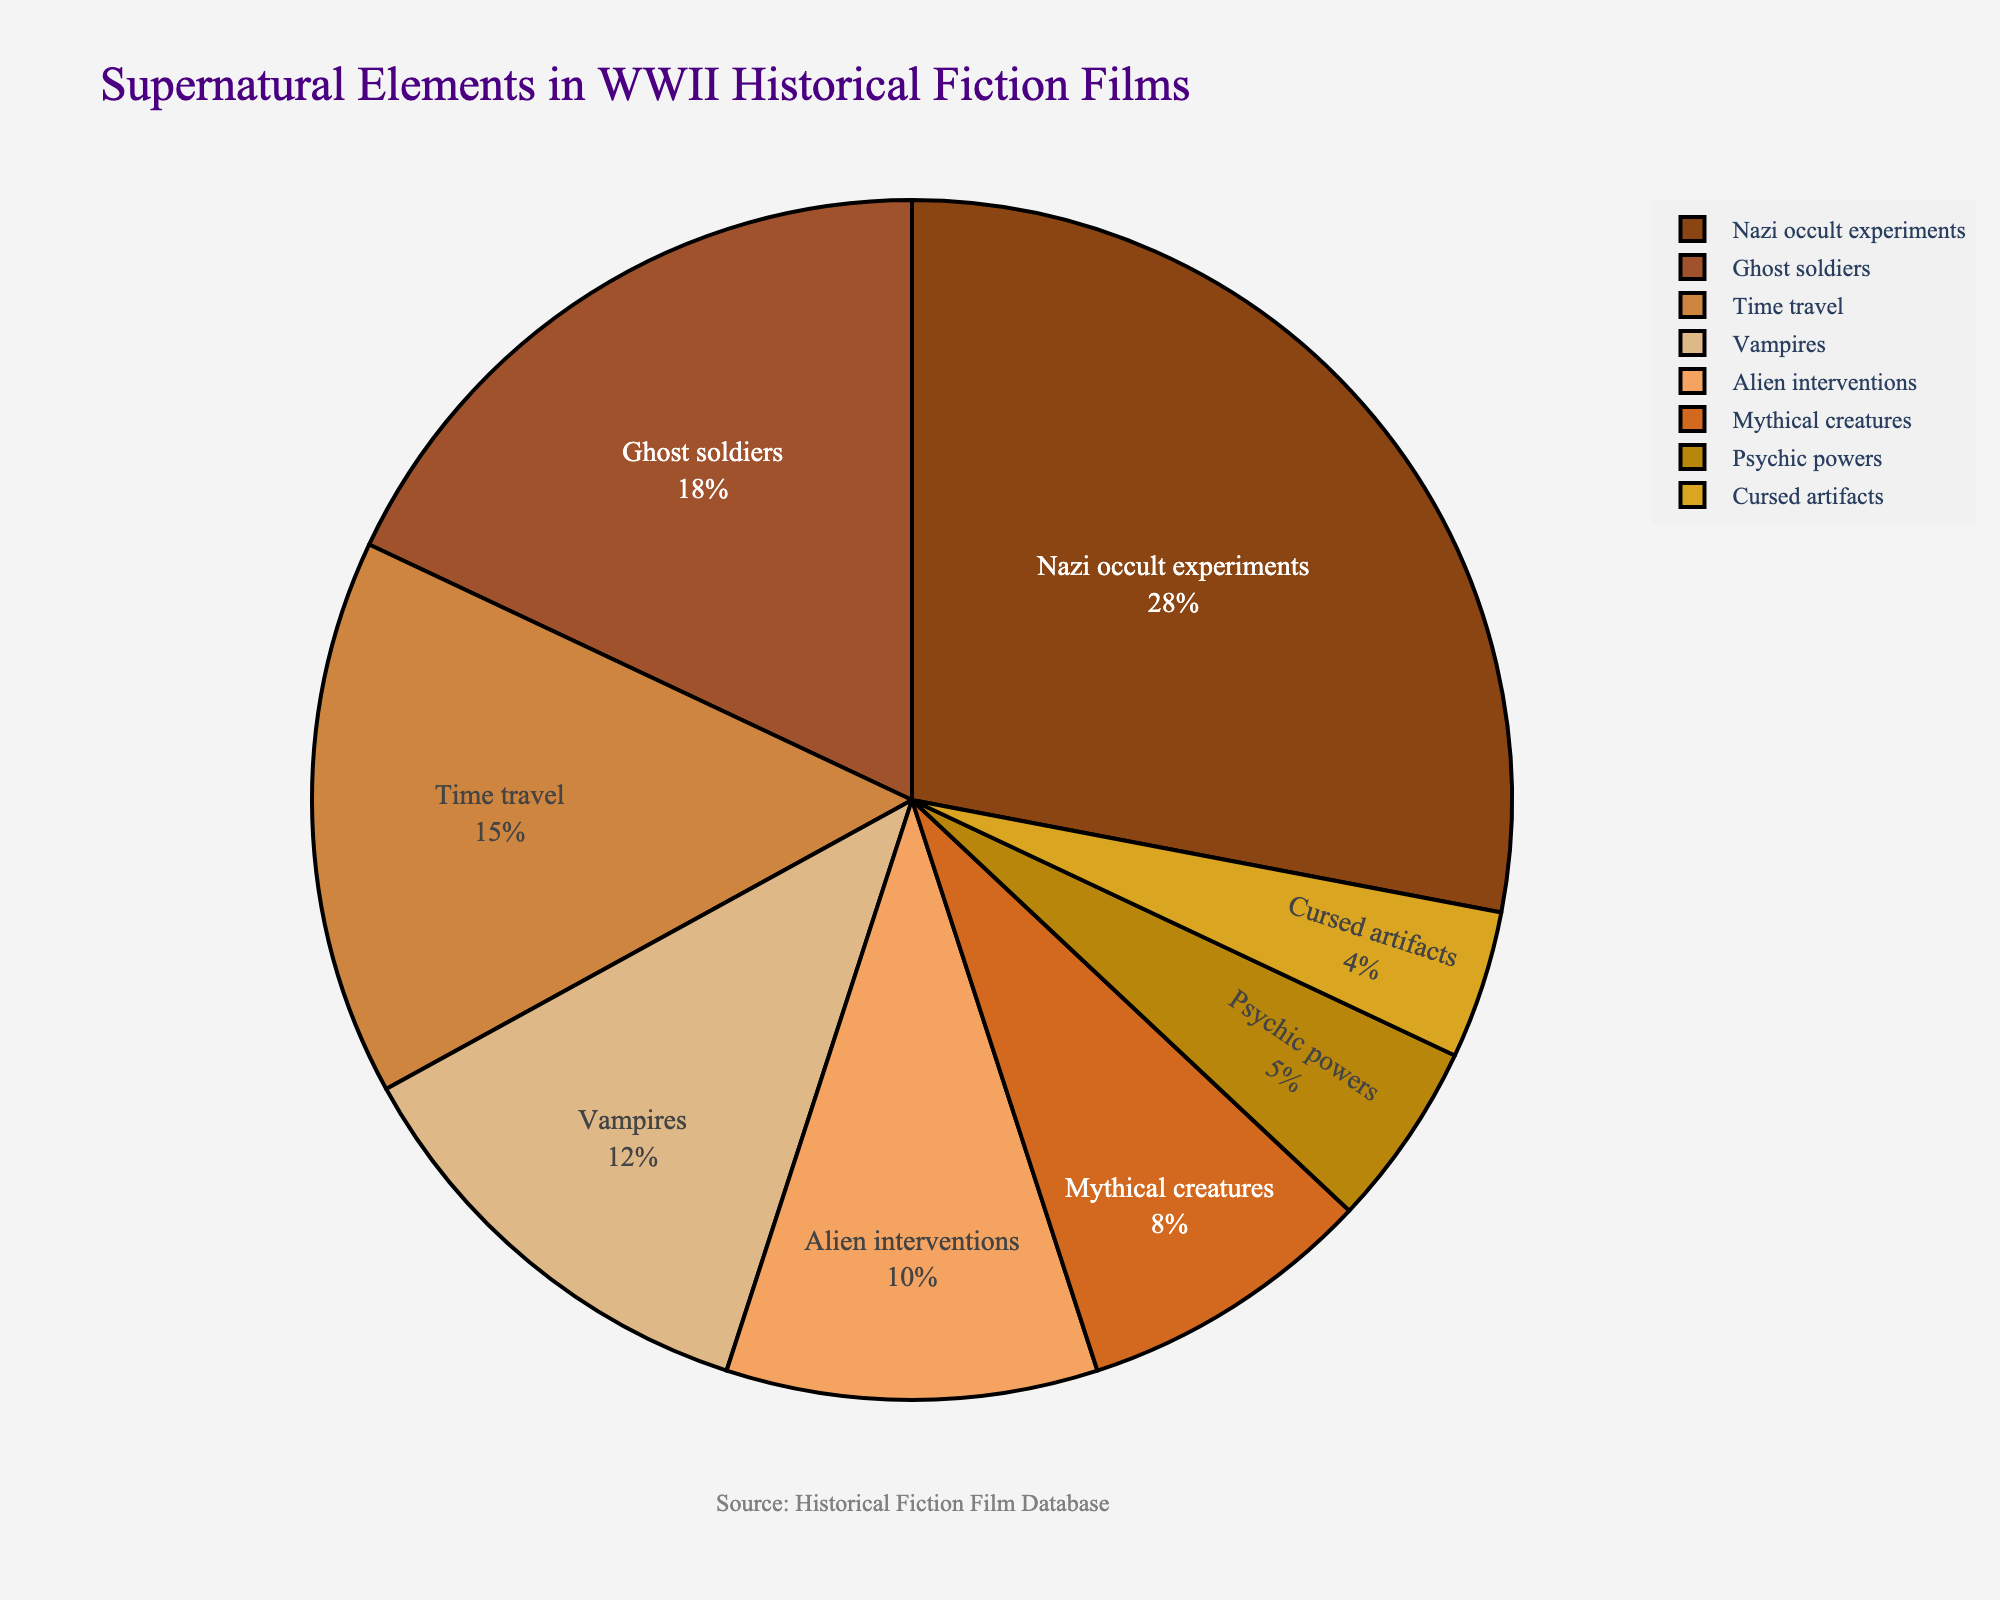Which category has the highest proportion? The largest slice of the pie chart represents the category with the highest percentage. The slice labeled "Nazi occult experiments" is visibly the largest and is marked with 28%.
Answer: Nazi occult experiments What is the combined percentage of "Ghost soldiers" and "Time travel"? To find the combined percentage, sum the individual percentages for "Ghost soldiers" (18%) and "Time travel" (15%). 18 + 15 = 33
Answer: 33 Which category features a lower proportion: "Vampires" or "Alien interventions"? Compare the slices labeled "Vampires" and "Alien interventions." "Vampires" has 12% and "Alien interventions" has 10%. Since 12 is greater than 10, "Alien interventions" features a lower proportion.
Answer: Alien interventions What percentage do "Psychic powers" and "Cursed artifacts" constitute together? Add the percentages of "Psychic powers" (5%) and "Cursed artifacts" (4%). 5 + 4 = 9
Answer: 9 How many categories have a proportion greater than 10%? Count the slices that are labeled with percentages greater than 10%. These are "Nazi occult experiments" (28%), "Ghost soldiers" (18%), "Time travel" (15%), and "Vampires" (12%). There are 4 such categories.
Answer: 4 What is the difference in proportions between the largest and smallest categories? Identify the percentages of the largest category, "Nazi occult experiments" (28%), and the smallest category, "Cursed artifacts" (4%). Subtract the smallest percentage from the largest. 28 - 4 = 24
Answer: 24 Which category has a proportion closest to 10%? Examine the pie chart for the slice labeled with a percentage nearest to 10%. "Alien interventions" is marked with 10%, making it the closest to 10%.
Answer: Alien interventions What is the proportion of categories that individually constitute less than 10% combined? Sum the percentages of categories with less than 10%, which include "Mythical creatures" (8%), "Psychic powers" (5%), and "Cursed artifacts" (4%). 8 + 5 + 4 = 17
Answer: 17 